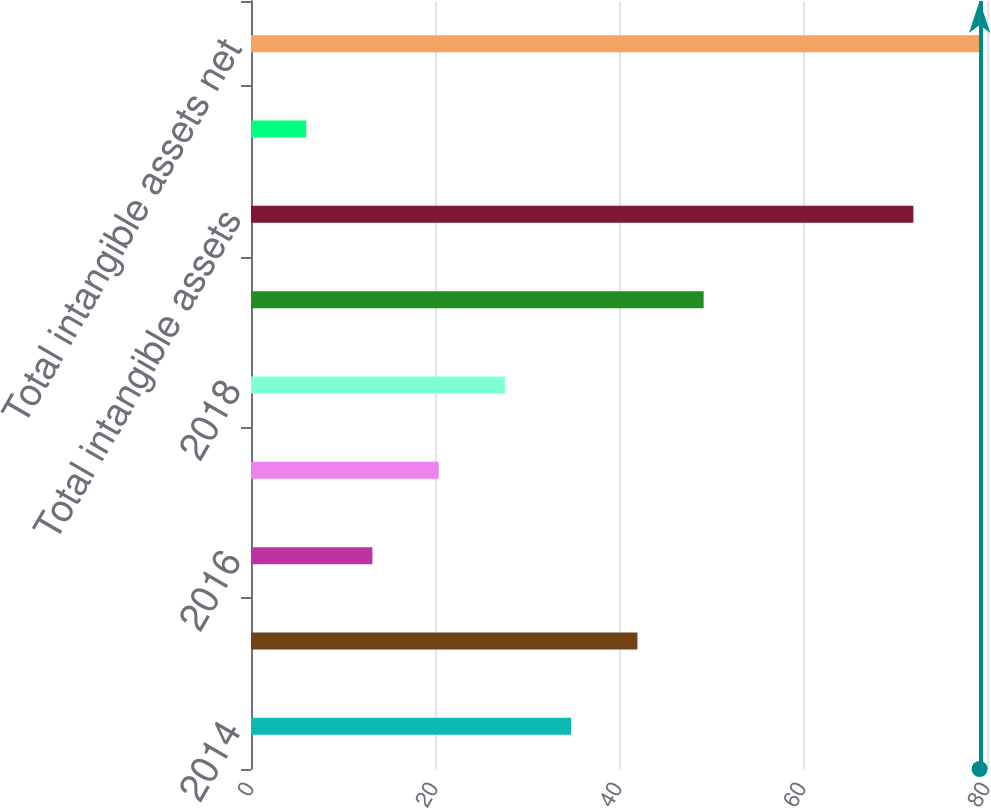Convert chart to OTSL. <chart><loc_0><loc_0><loc_500><loc_500><bar_chart><fcel>2014<fcel>2015<fcel>2016<fcel>2017<fcel>2018<fcel>2019 and thereafter<fcel>Total intangible assets<fcel>In-process research and<fcel>Total intangible assets net<nl><fcel>34.8<fcel>42<fcel>13.2<fcel>20.4<fcel>27.6<fcel>49.2<fcel>72<fcel>6<fcel>79.2<nl></chart> 